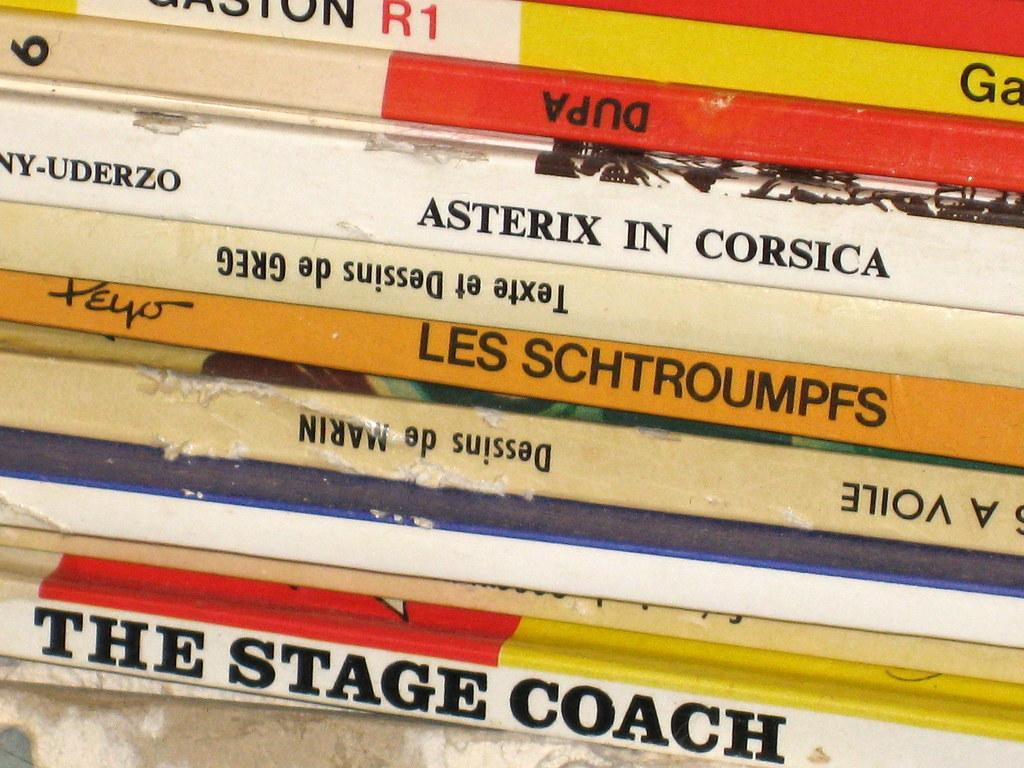<image>
Create a compact narrative representing the image presented. The bottom book in the stack of books is titled The stage coach. 